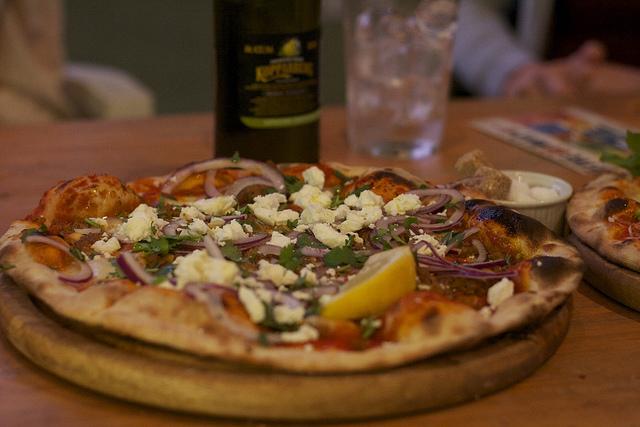What is in the glass?
Short answer required. Water. What single fruit item is on the pizza?
Keep it brief. Lemon. Is the food shown sweet?
Answer briefly. No. This meal is lunch?
Answer briefly. Yes. Is this a vegan meal?
Quick response, please. No. What kind of cheese is featured on the topping of this pizza?
Concise answer only. Feta. What color is the plate?
Give a very brief answer. Brown. Is there cheese on the pizza?
Keep it brief. Yes. What utensil will be used?
Write a very short answer. Knife. Does the crust look crunchy?
Keep it brief. Yes. What type of food is this: Dessert or Appetizer?
Give a very brief answer. Appetizer. What kind of cheese is on the pizza?
Concise answer only. Feta. What sort of cheese is served here?
Keep it brief. Feta. What method of cooking is used to make these?
Answer briefly. Baking. Is this a healthy meal?
Concise answer only. No. What dish is photographed on the table?
Keep it brief. Pizza. What is the table top made of?
Keep it brief. Wood. What is the color of the glass?
Keep it brief. Clear. What kind of food is this?
Quick response, please. Pizza. 